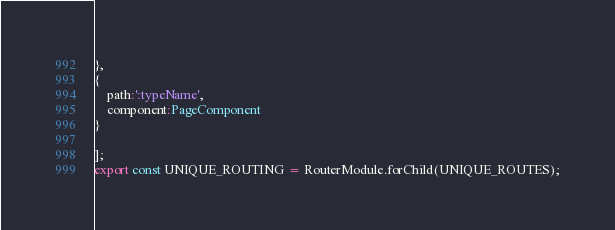Convert code to text. <code><loc_0><loc_0><loc_500><loc_500><_TypeScript_>},
{
	path:':typeName',
	component:PageComponent
}

];
export const UNIQUE_ROUTING = RouterModule.forChild(UNIQUE_ROUTES);</code> 